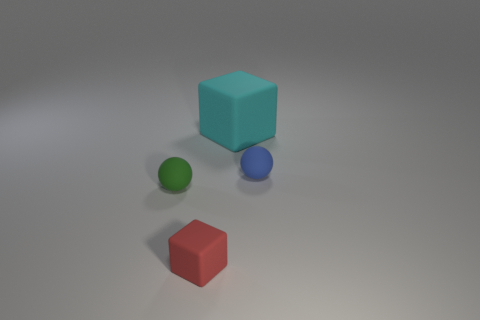Add 3 large cyan cylinders. How many objects exist? 7 Subtract all red blocks. How many blocks are left? 1 Add 3 yellow matte objects. How many yellow matte objects exist? 3 Subtract 0 red balls. How many objects are left? 4 Subtract all red cubes. Subtract all red cylinders. How many cubes are left? 1 Subtract all purple blocks. How many cyan spheres are left? 0 Subtract all red spheres. Subtract all cyan rubber cubes. How many objects are left? 3 Add 3 small green matte objects. How many small green matte objects are left? 4 